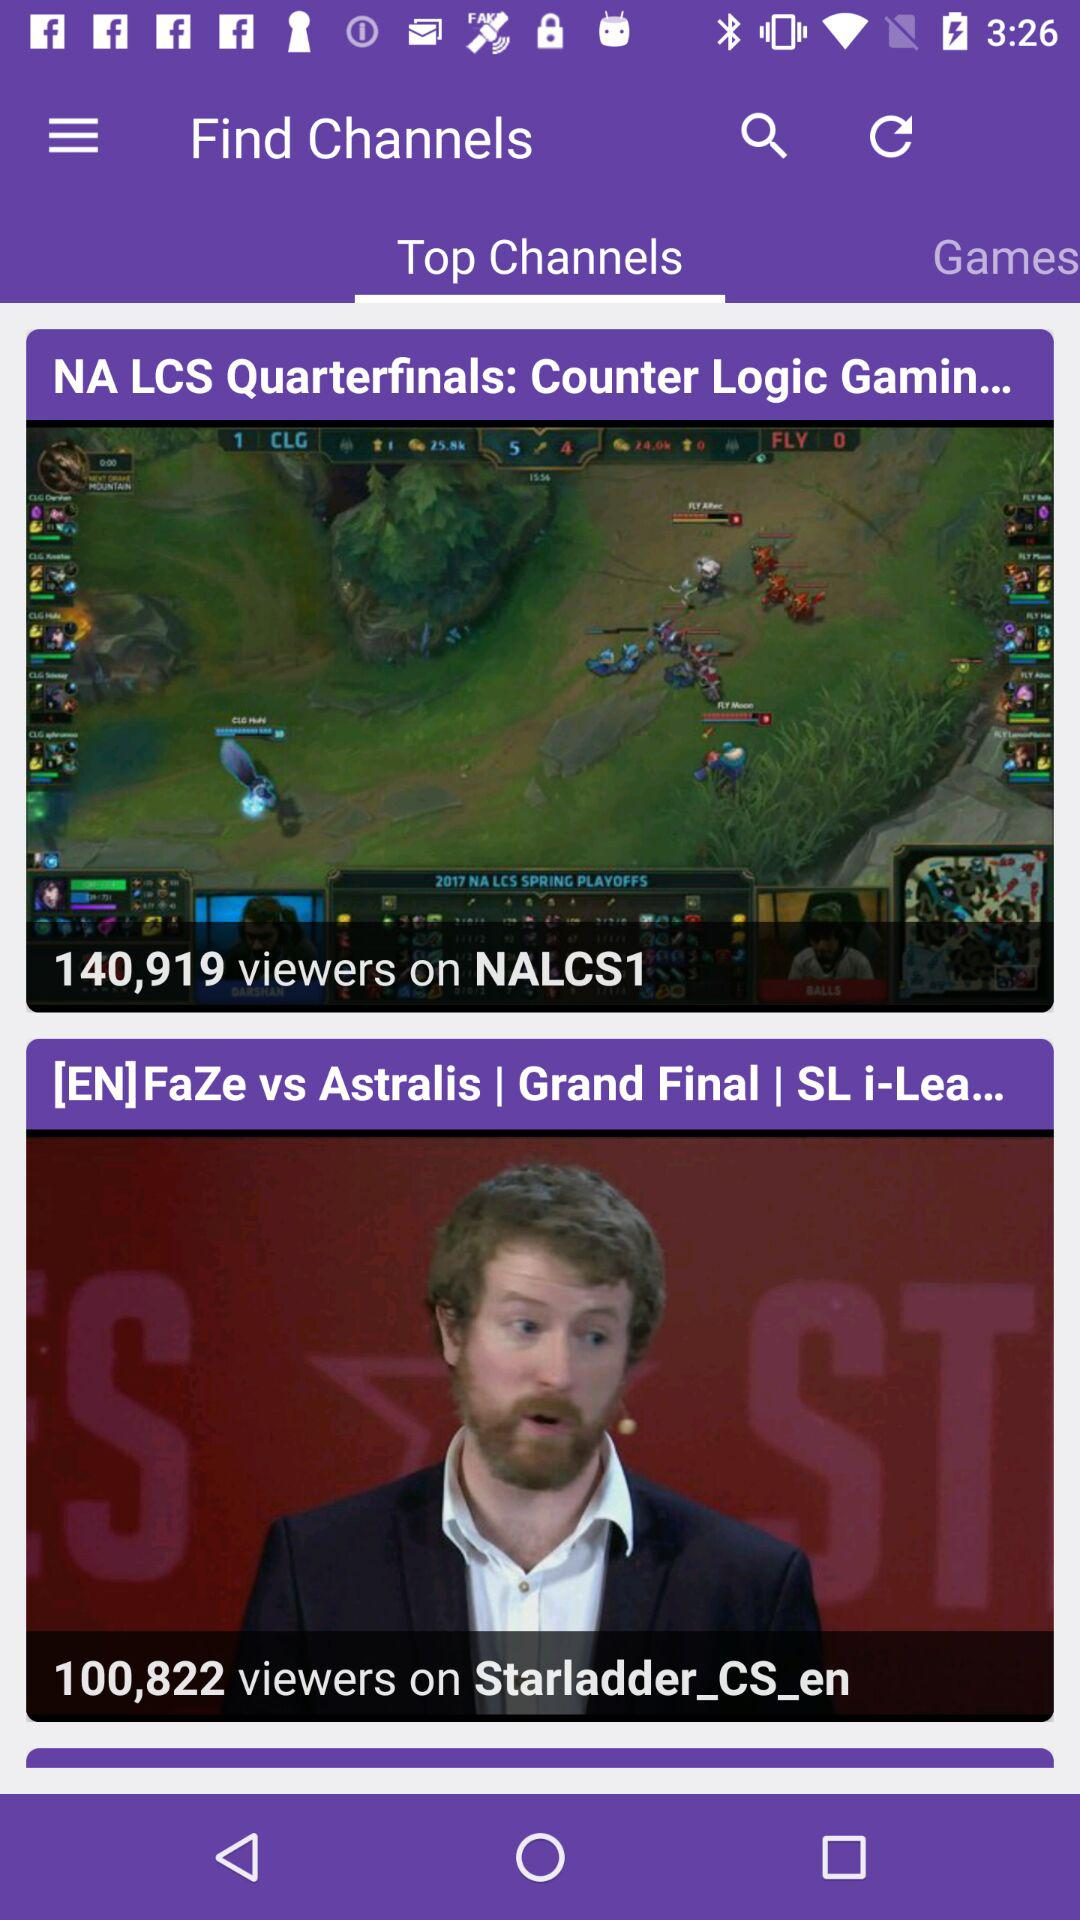How many viewers are there for the grand final? There are 100,822 viewers for the grand final. 